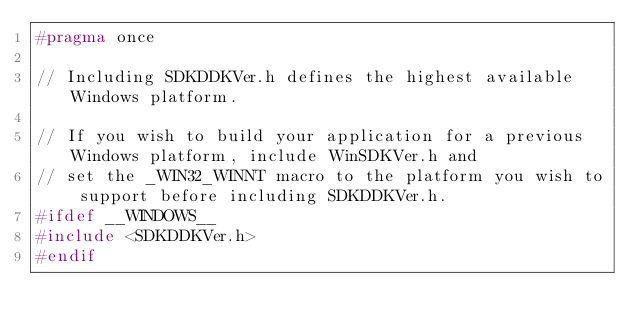Convert code to text. <code><loc_0><loc_0><loc_500><loc_500><_C_>#pragma once

// Including SDKDDKVer.h defines the highest available Windows platform.

// If you wish to build your application for a previous Windows platform, include WinSDKVer.h and
// set the _WIN32_WINNT macro to the platform you wish to support before including SDKDDKVer.h.
#ifdef __WINDOWS__
#include <SDKDDKVer.h>
#endif
</code> 